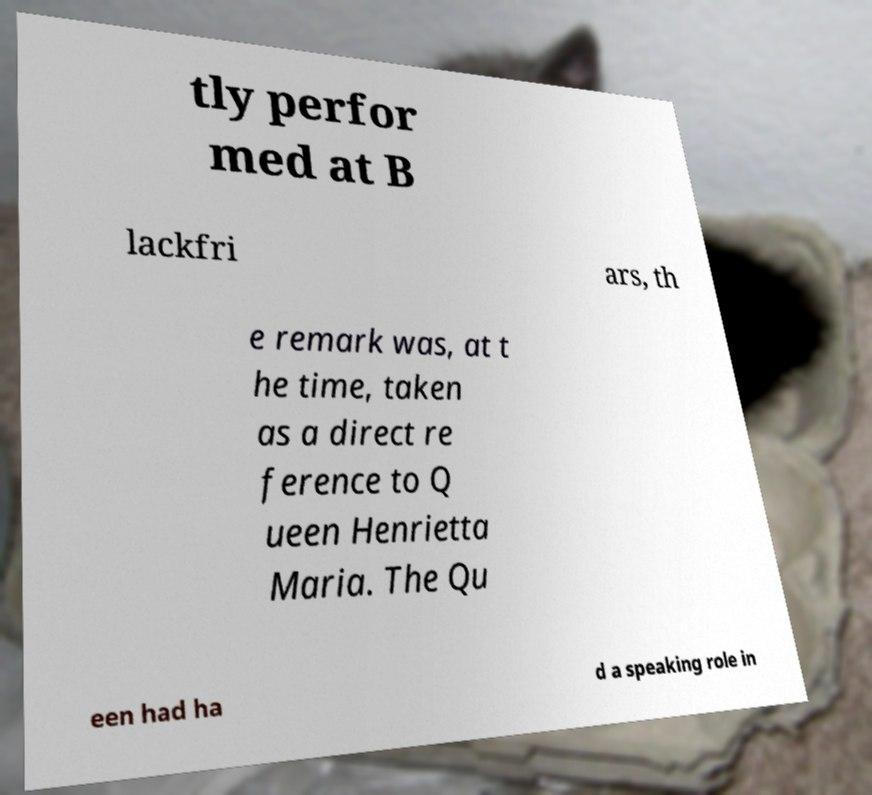Could you extract and type out the text from this image? tly perfor med at B lackfri ars, th e remark was, at t he time, taken as a direct re ference to Q ueen Henrietta Maria. The Qu een had ha d a speaking role in 